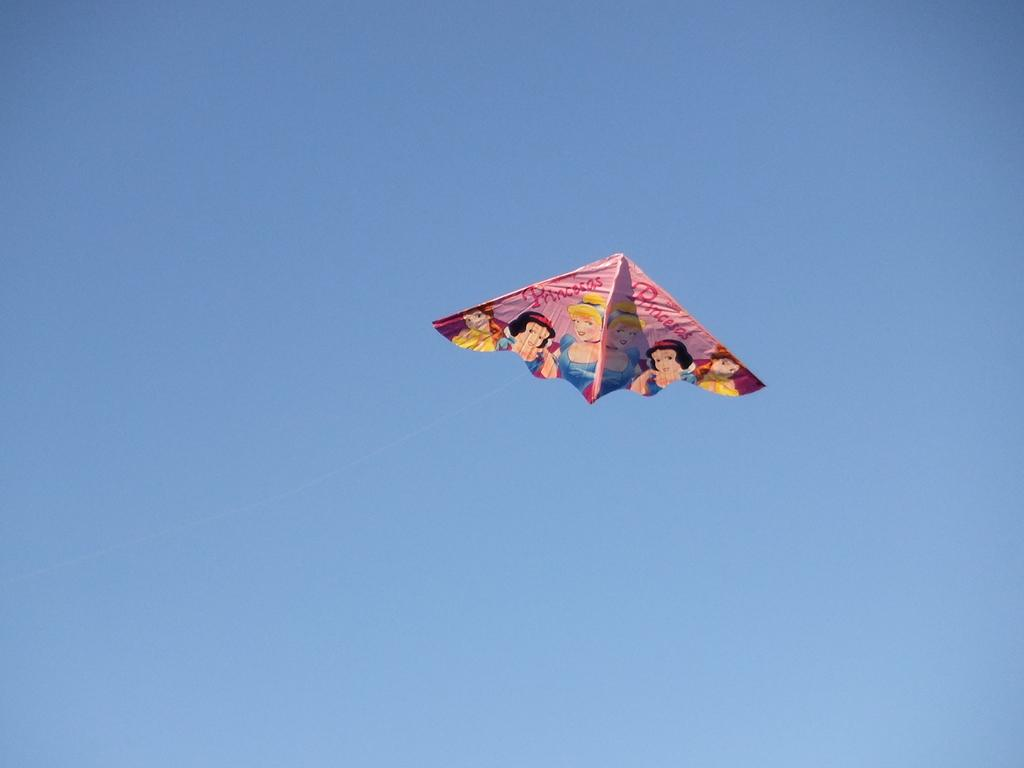What is the main subject in the foreground of the image? There is a kite in the air in the foreground of the image. What can be seen in the background of the image? There is sky visible in the background of the image. How much debt is the kite in the image responsible for? There is no mention of debt in the image, and the kite is not a sentient being capable of being responsible for debt. 